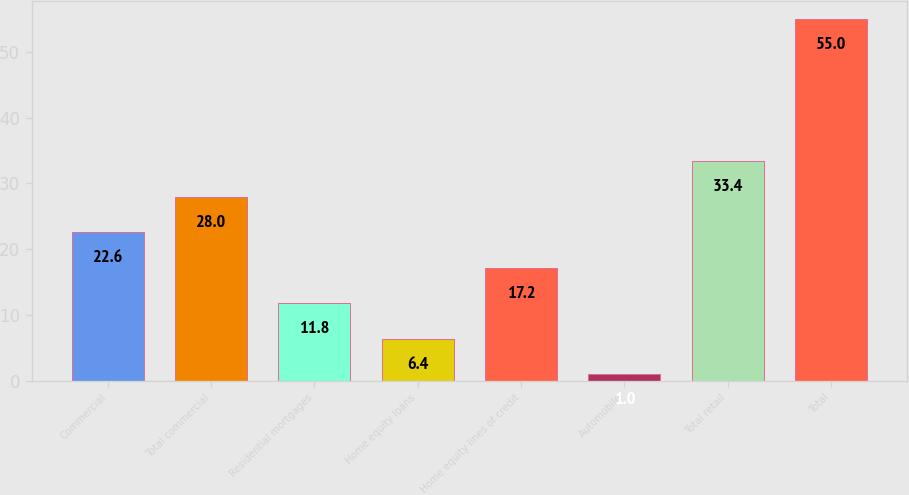Convert chart to OTSL. <chart><loc_0><loc_0><loc_500><loc_500><bar_chart><fcel>Commercial<fcel>Total commercial<fcel>Residential mortgages<fcel>Home equity loans<fcel>Home equity lines of credit<fcel>Automobile<fcel>Total retail<fcel>Total<nl><fcel>22.6<fcel>28<fcel>11.8<fcel>6.4<fcel>17.2<fcel>1<fcel>33.4<fcel>55<nl></chart> 